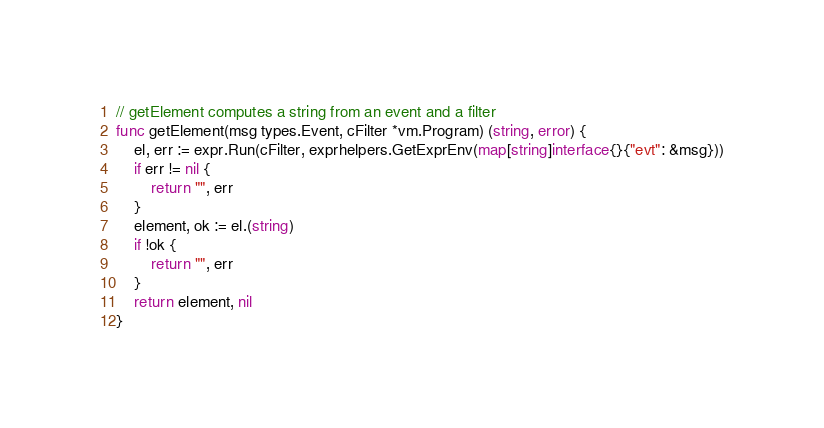Convert code to text. <code><loc_0><loc_0><loc_500><loc_500><_Go_>
// getElement computes a string from an event and a filter
func getElement(msg types.Event, cFilter *vm.Program) (string, error) {
	el, err := expr.Run(cFilter, exprhelpers.GetExprEnv(map[string]interface{}{"evt": &msg}))
	if err != nil {
		return "", err
	}
	element, ok := el.(string)
	if !ok {
		return "", err
	}
	return element, nil
}
</code> 